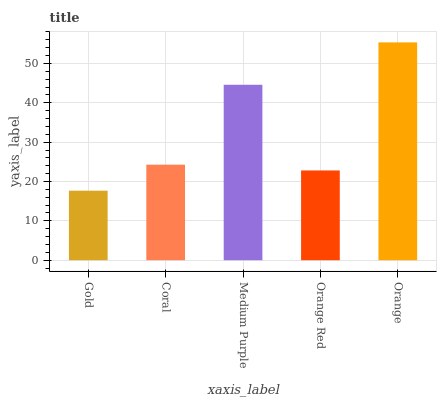Is Gold the minimum?
Answer yes or no. Yes. Is Orange the maximum?
Answer yes or no. Yes. Is Coral the minimum?
Answer yes or no. No. Is Coral the maximum?
Answer yes or no. No. Is Coral greater than Gold?
Answer yes or no. Yes. Is Gold less than Coral?
Answer yes or no. Yes. Is Gold greater than Coral?
Answer yes or no. No. Is Coral less than Gold?
Answer yes or no. No. Is Coral the high median?
Answer yes or no. Yes. Is Coral the low median?
Answer yes or no. Yes. Is Medium Purple the high median?
Answer yes or no. No. Is Orange the low median?
Answer yes or no. No. 